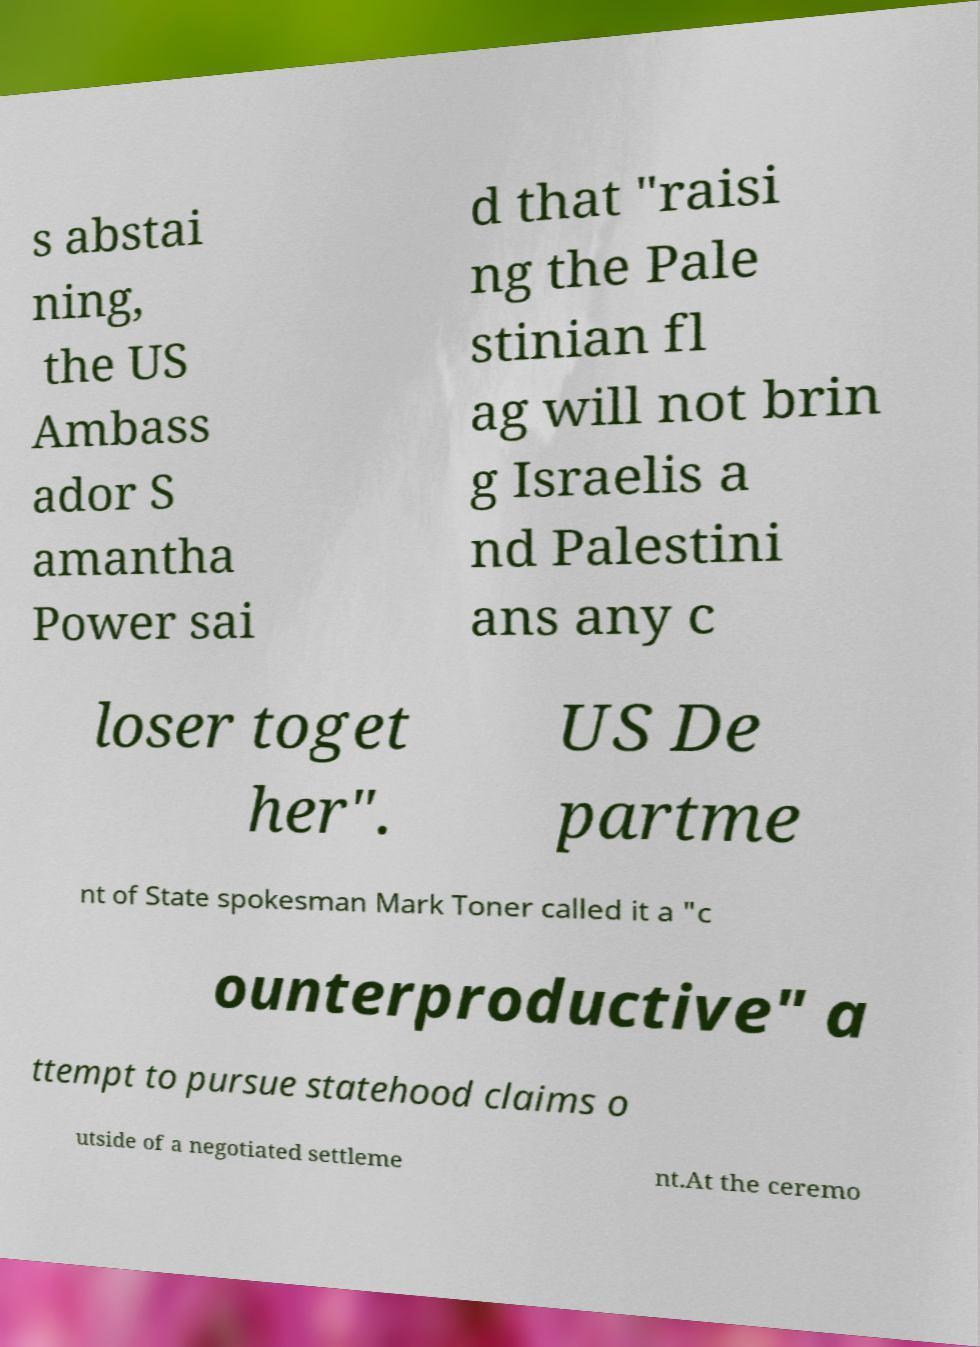For documentation purposes, I need the text within this image transcribed. Could you provide that? s abstai ning, the US Ambass ador S amantha Power sai d that "raisi ng the Pale stinian fl ag will not brin g Israelis a nd Palestini ans any c loser toget her". US De partme nt of State spokesman Mark Toner called it a "c ounterproductive" a ttempt to pursue statehood claims o utside of a negotiated settleme nt.At the ceremo 